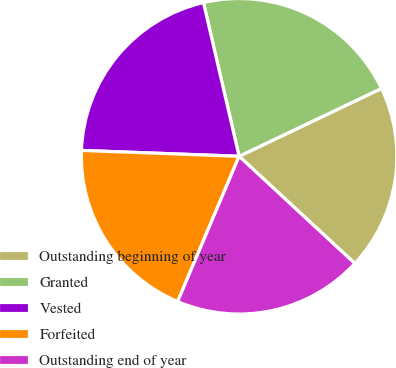<chart> <loc_0><loc_0><loc_500><loc_500><pie_chart><fcel>Outstanding beginning of year<fcel>Granted<fcel>Vested<fcel>Forfeited<fcel>Outstanding end of year<nl><fcel>18.97%<fcel>21.55%<fcel>20.78%<fcel>19.22%<fcel>19.48%<nl></chart> 